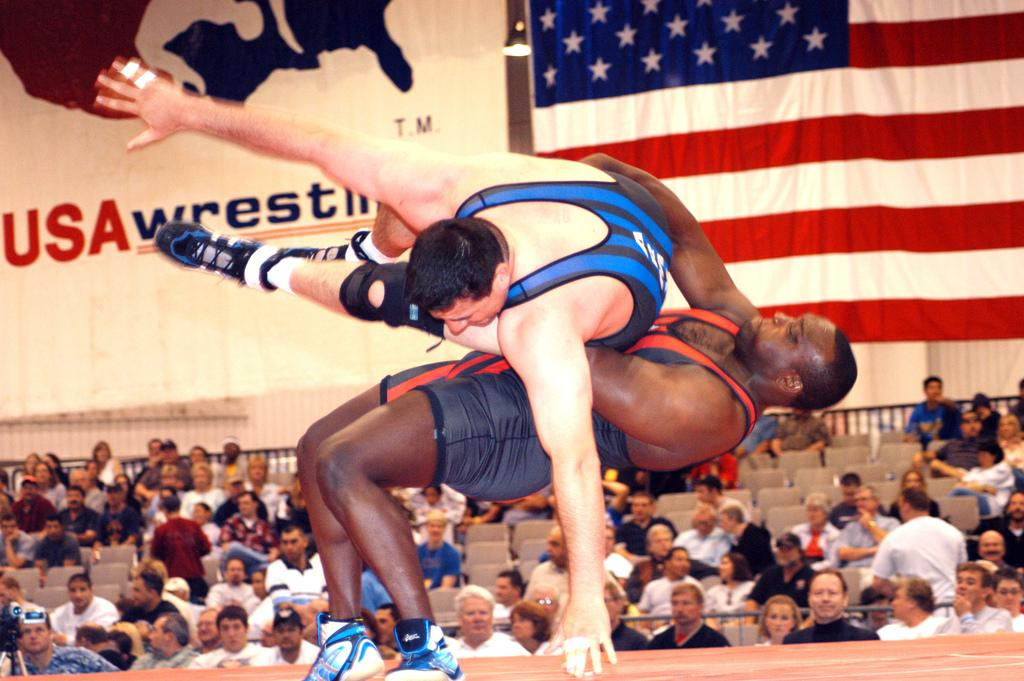<image>
Share a concise interpretation of the image provided. the words USA Wrestling is on the wall of a place 